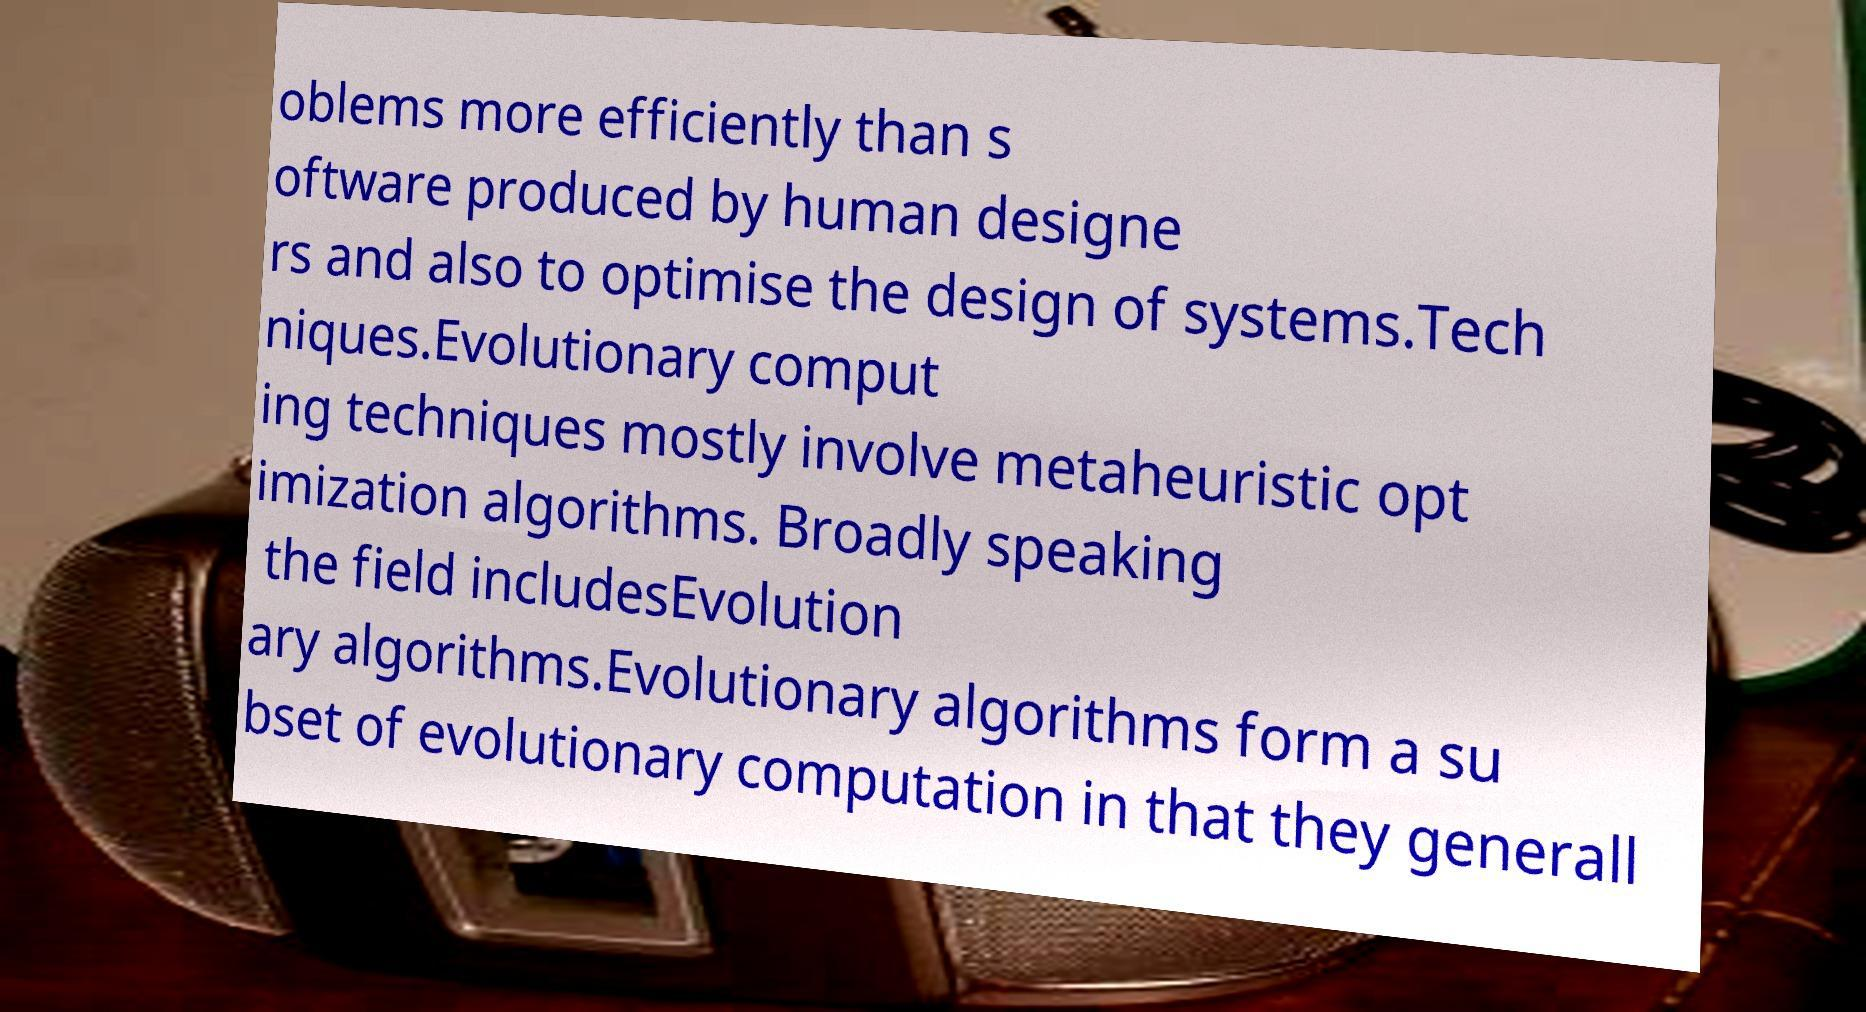Can you read and provide the text displayed in the image?This photo seems to have some interesting text. Can you extract and type it out for me? oblems more efficiently than s oftware produced by human designe rs and also to optimise the design of systems.Tech niques.Evolutionary comput ing techniques mostly involve metaheuristic opt imization algorithms. Broadly speaking the field includesEvolution ary algorithms.Evolutionary algorithms form a su bset of evolutionary computation in that they generall 